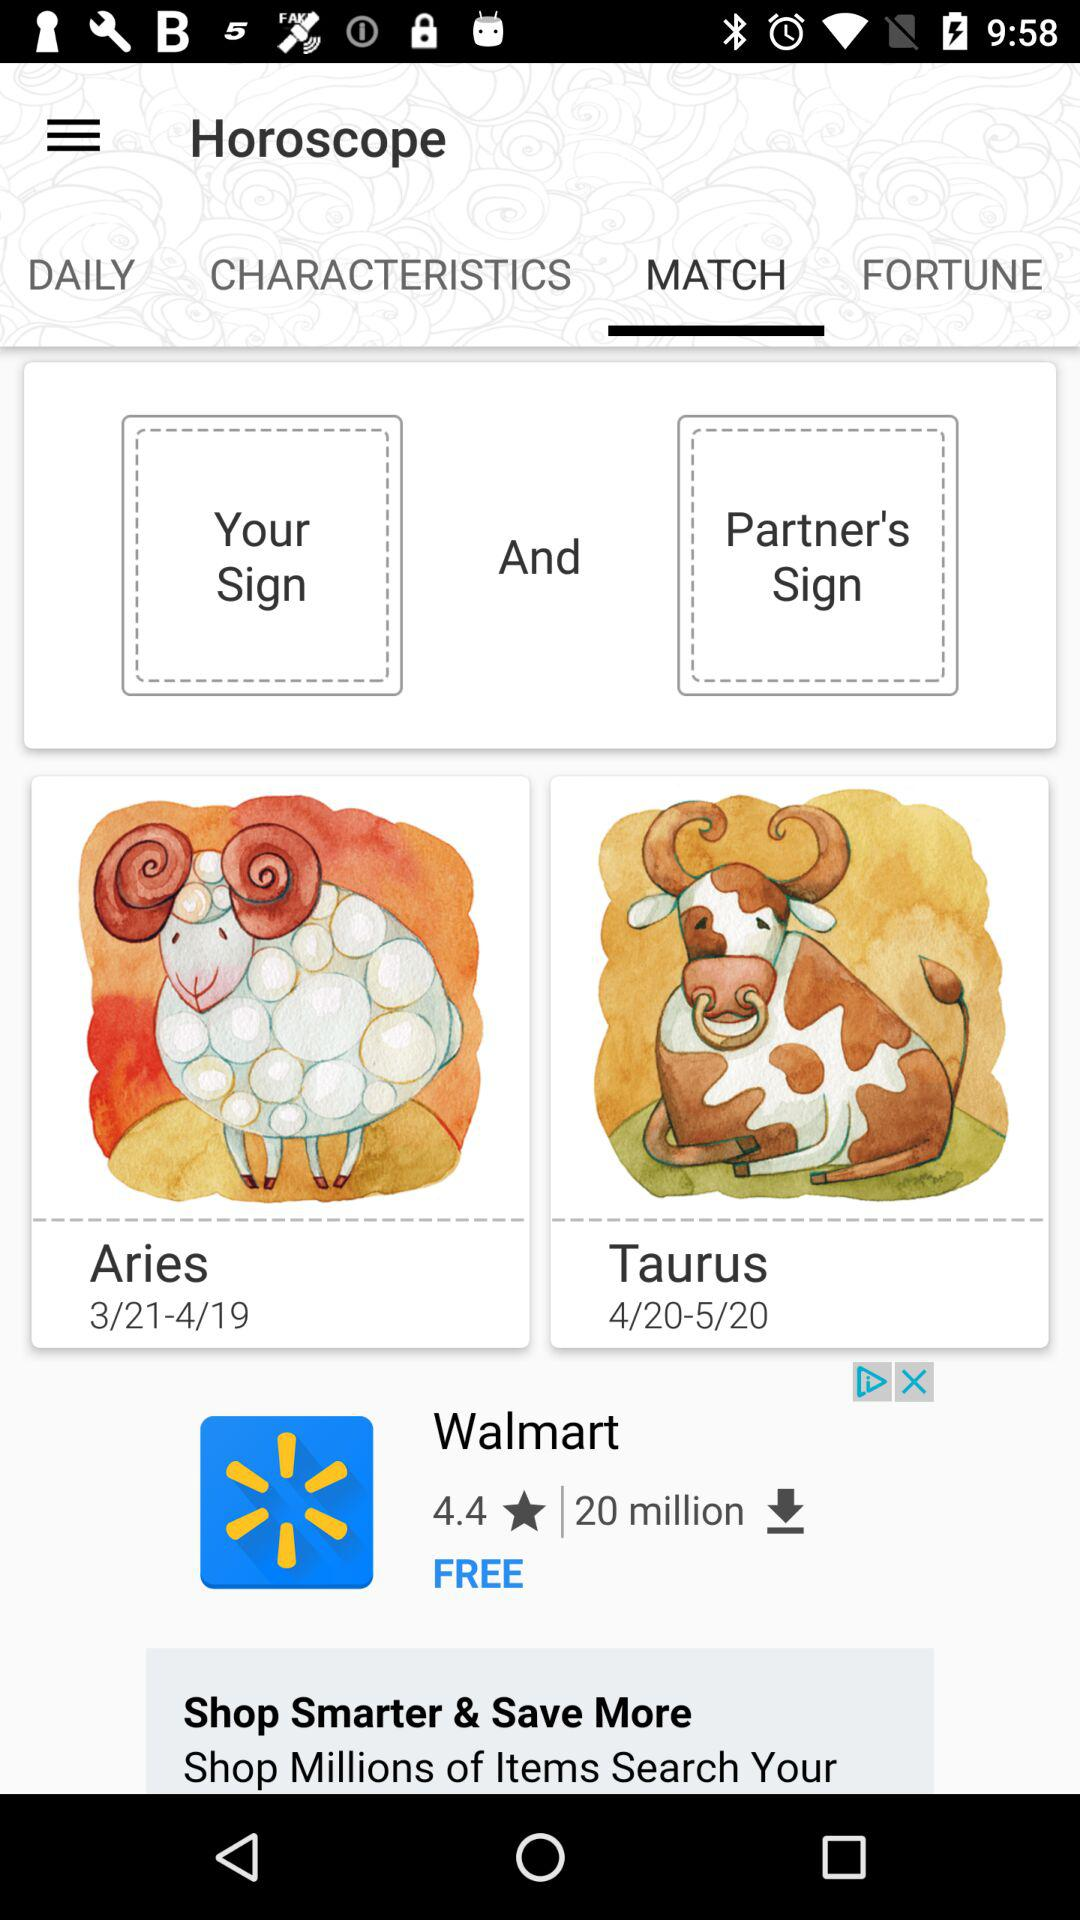What is the mentioned date range for the zodiac sign Aries? The mentioned date range for the zodiac sign Aries is 3/21–4/19. 